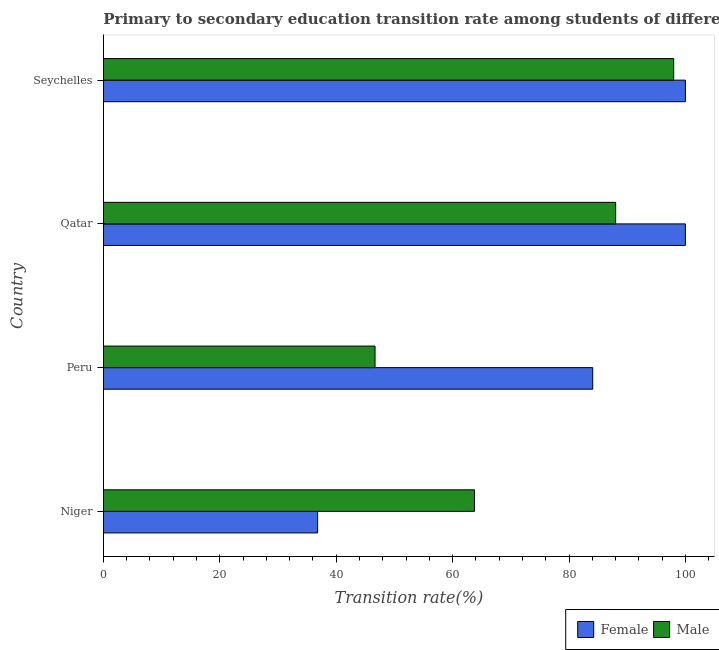How many different coloured bars are there?
Keep it short and to the point. 2. Are the number of bars on each tick of the Y-axis equal?
Your answer should be very brief. Yes. How many bars are there on the 2nd tick from the top?
Your answer should be very brief. 2. How many bars are there on the 4th tick from the bottom?
Ensure brevity in your answer.  2. What is the label of the 1st group of bars from the top?
Offer a very short reply. Seychelles. Across all countries, what is the minimum transition rate among female students?
Your response must be concise. 36.81. In which country was the transition rate among male students maximum?
Your response must be concise. Seychelles. What is the total transition rate among male students in the graph?
Offer a very short reply. 296.44. What is the difference between the transition rate among male students in Peru and that in Seychelles?
Your response must be concise. -51.32. What is the difference between the transition rate among female students in Niger and the transition rate among male students in Peru?
Ensure brevity in your answer.  -9.87. What is the average transition rate among male students per country?
Your answer should be compact. 74.11. What is the difference between the transition rate among male students and transition rate among female students in Seychelles?
Give a very brief answer. -2.01. In how many countries, is the transition rate among female students greater than 52 %?
Ensure brevity in your answer.  3. What is the ratio of the transition rate among female students in Niger to that in Peru?
Offer a terse response. 0.44. What is the difference between the highest and the lowest transition rate among female students?
Offer a terse response. 63.19. In how many countries, is the transition rate among male students greater than the average transition rate among male students taken over all countries?
Your answer should be compact. 2. What does the 2nd bar from the top in Niger represents?
Offer a very short reply. Female. What does the 2nd bar from the bottom in Seychelles represents?
Your answer should be compact. Male. How many bars are there?
Your response must be concise. 8. Are the values on the major ticks of X-axis written in scientific E-notation?
Make the answer very short. No. Does the graph contain any zero values?
Offer a terse response. No. How are the legend labels stacked?
Your response must be concise. Horizontal. What is the title of the graph?
Offer a very short reply. Primary to secondary education transition rate among students of different countries. What is the label or title of the X-axis?
Keep it short and to the point. Transition rate(%). What is the label or title of the Y-axis?
Ensure brevity in your answer.  Country. What is the Transition rate(%) of Female in Niger?
Ensure brevity in your answer.  36.81. What is the Transition rate(%) in Male in Niger?
Your answer should be very brief. 63.76. What is the Transition rate(%) of Female in Peru?
Your response must be concise. 84.08. What is the Transition rate(%) in Male in Peru?
Give a very brief answer. 46.67. What is the Transition rate(%) in Male in Qatar?
Your answer should be compact. 88.02. What is the Transition rate(%) in Female in Seychelles?
Your answer should be very brief. 100. What is the Transition rate(%) in Male in Seychelles?
Offer a terse response. 97.99. Across all countries, what is the maximum Transition rate(%) of Male?
Offer a very short reply. 97.99. Across all countries, what is the minimum Transition rate(%) of Female?
Provide a short and direct response. 36.81. Across all countries, what is the minimum Transition rate(%) in Male?
Your response must be concise. 46.67. What is the total Transition rate(%) in Female in the graph?
Keep it short and to the point. 320.88. What is the total Transition rate(%) in Male in the graph?
Your answer should be compact. 296.44. What is the difference between the Transition rate(%) of Female in Niger and that in Peru?
Ensure brevity in your answer.  -47.27. What is the difference between the Transition rate(%) in Male in Niger and that in Peru?
Your response must be concise. 17.09. What is the difference between the Transition rate(%) in Female in Niger and that in Qatar?
Provide a succinct answer. -63.19. What is the difference between the Transition rate(%) in Male in Niger and that in Qatar?
Provide a short and direct response. -24.25. What is the difference between the Transition rate(%) of Female in Niger and that in Seychelles?
Make the answer very short. -63.19. What is the difference between the Transition rate(%) of Male in Niger and that in Seychelles?
Provide a short and direct response. -34.23. What is the difference between the Transition rate(%) in Female in Peru and that in Qatar?
Provide a succinct answer. -15.92. What is the difference between the Transition rate(%) in Male in Peru and that in Qatar?
Provide a short and direct response. -41.34. What is the difference between the Transition rate(%) in Female in Peru and that in Seychelles?
Ensure brevity in your answer.  -15.92. What is the difference between the Transition rate(%) in Male in Peru and that in Seychelles?
Make the answer very short. -51.32. What is the difference between the Transition rate(%) in Male in Qatar and that in Seychelles?
Offer a very short reply. -9.97. What is the difference between the Transition rate(%) of Female in Niger and the Transition rate(%) of Male in Peru?
Provide a short and direct response. -9.87. What is the difference between the Transition rate(%) in Female in Niger and the Transition rate(%) in Male in Qatar?
Offer a terse response. -51.21. What is the difference between the Transition rate(%) in Female in Niger and the Transition rate(%) in Male in Seychelles?
Give a very brief answer. -61.18. What is the difference between the Transition rate(%) of Female in Peru and the Transition rate(%) of Male in Qatar?
Provide a succinct answer. -3.94. What is the difference between the Transition rate(%) of Female in Peru and the Transition rate(%) of Male in Seychelles?
Keep it short and to the point. -13.91. What is the difference between the Transition rate(%) of Female in Qatar and the Transition rate(%) of Male in Seychelles?
Your answer should be compact. 2.01. What is the average Transition rate(%) of Female per country?
Your answer should be compact. 80.22. What is the average Transition rate(%) in Male per country?
Provide a succinct answer. 74.11. What is the difference between the Transition rate(%) of Female and Transition rate(%) of Male in Niger?
Keep it short and to the point. -26.96. What is the difference between the Transition rate(%) in Female and Transition rate(%) in Male in Peru?
Your answer should be very brief. 37.4. What is the difference between the Transition rate(%) in Female and Transition rate(%) in Male in Qatar?
Your response must be concise. 11.98. What is the difference between the Transition rate(%) in Female and Transition rate(%) in Male in Seychelles?
Offer a very short reply. 2.01. What is the ratio of the Transition rate(%) of Female in Niger to that in Peru?
Keep it short and to the point. 0.44. What is the ratio of the Transition rate(%) in Male in Niger to that in Peru?
Your response must be concise. 1.37. What is the ratio of the Transition rate(%) of Female in Niger to that in Qatar?
Keep it short and to the point. 0.37. What is the ratio of the Transition rate(%) of Male in Niger to that in Qatar?
Your answer should be compact. 0.72. What is the ratio of the Transition rate(%) of Female in Niger to that in Seychelles?
Provide a succinct answer. 0.37. What is the ratio of the Transition rate(%) of Male in Niger to that in Seychelles?
Keep it short and to the point. 0.65. What is the ratio of the Transition rate(%) of Female in Peru to that in Qatar?
Make the answer very short. 0.84. What is the ratio of the Transition rate(%) in Male in Peru to that in Qatar?
Provide a succinct answer. 0.53. What is the ratio of the Transition rate(%) of Female in Peru to that in Seychelles?
Make the answer very short. 0.84. What is the ratio of the Transition rate(%) in Male in Peru to that in Seychelles?
Keep it short and to the point. 0.48. What is the ratio of the Transition rate(%) in Female in Qatar to that in Seychelles?
Offer a terse response. 1. What is the ratio of the Transition rate(%) in Male in Qatar to that in Seychelles?
Keep it short and to the point. 0.9. What is the difference between the highest and the second highest Transition rate(%) in Male?
Provide a short and direct response. 9.97. What is the difference between the highest and the lowest Transition rate(%) in Female?
Give a very brief answer. 63.19. What is the difference between the highest and the lowest Transition rate(%) of Male?
Offer a terse response. 51.32. 